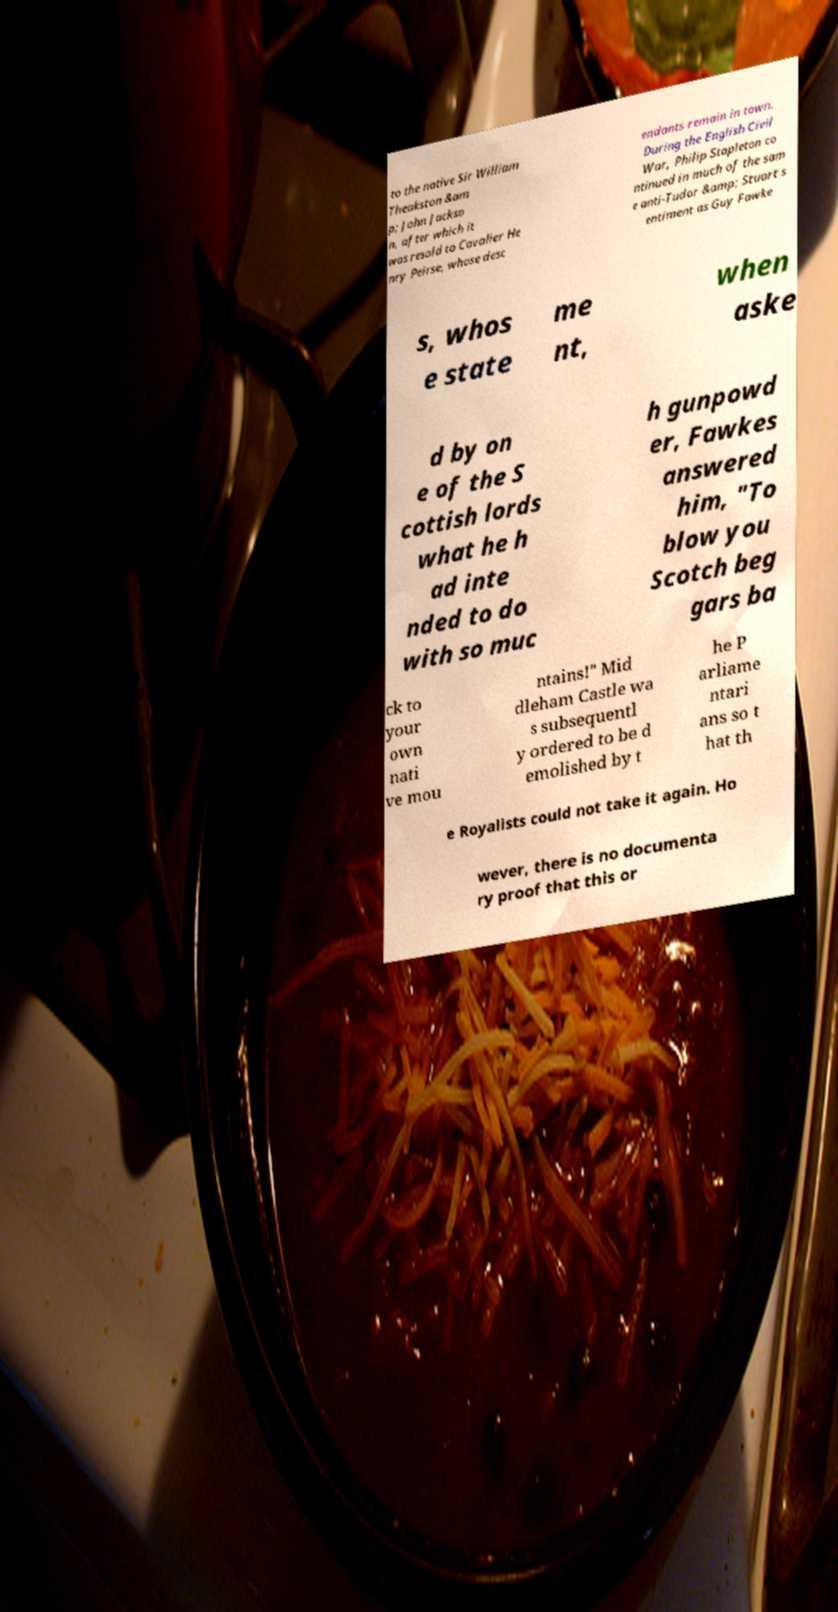What messages or text are displayed in this image? I need them in a readable, typed format. to the native Sir William Theakston &am p; John Jackso n, after which it was resold to Cavalier He nry Peirse, whose desc endants remain in town. During the English Civil War, Philip Stapleton co ntinued in much of the sam e anti-Tudor &amp; Stuart s entiment as Guy Fawke s, whos e state me nt, when aske d by on e of the S cottish lords what he h ad inte nded to do with so muc h gunpowd er, Fawkes answered him, "To blow you Scotch beg gars ba ck to your own nati ve mou ntains!" Mid dleham Castle wa s subsequentl y ordered to be d emolished by t he P arliame ntari ans so t hat th e Royalists could not take it again. Ho wever, there is no documenta ry proof that this or 